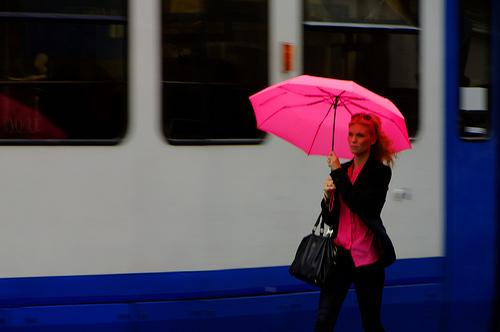Mention the color and item the woman is holding in her hand. The woman is holding a pink umbrella in her hand. State the number of objects in the image related to the woman's clothing and accessories. There are seven objects related to the woman's clothing and accessories: pink umbrella, black jacket, pink shirt, black pants, sun glasses, black bag, and pink strap on the end of the umbrella. What is the overall sentiment of the image? The overall sentiment of the image is calm and relaxed. Come up with a question that involves reasoning based on the image. Given the presence of raindrops on the train windows, it is more likely that the woman is trying to protect herself from rain with the umbrella. Highlight the interactions between objects in the image. The woman is holding a pink umbrella to protect herself from rain, wearing sunglasses on her head, and carrying a black handbag while walking next to a train. List the woman's attire and accessories. The woman is wearing a black jacket, pink shirt, black pants, and sun glasses, and is holding a pink umbrella and a black bag. What type of bag is the woman carrying? The woman is carrying a black leather handbag. Identify the number of windows present in the train. There are three windows in a row on the train. Considering the image quality aspects, mention any areas that could be improved. Some of the image elements, such as the woman's face and the train windows, could benefit from increased sharpness and contrast. Describe the primary color palette of the image. The primary color palette consists of pink, black, white, and blue. 